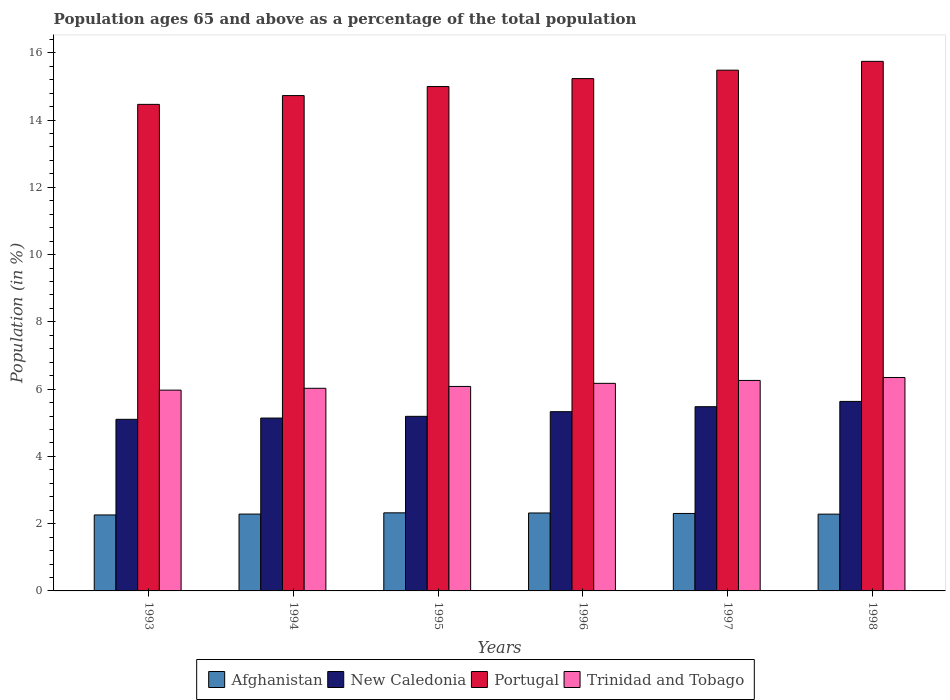Are the number of bars on each tick of the X-axis equal?
Give a very brief answer. Yes. How many bars are there on the 6th tick from the left?
Offer a very short reply. 4. What is the percentage of the population ages 65 and above in Portugal in 1996?
Keep it short and to the point. 15.23. Across all years, what is the maximum percentage of the population ages 65 and above in Trinidad and Tobago?
Make the answer very short. 6.35. Across all years, what is the minimum percentage of the population ages 65 and above in Trinidad and Tobago?
Ensure brevity in your answer.  5.97. In which year was the percentage of the population ages 65 and above in Trinidad and Tobago maximum?
Keep it short and to the point. 1998. What is the total percentage of the population ages 65 and above in Portugal in the graph?
Give a very brief answer. 90.64. What is the difference between the percentage of the population ages 65 and above in Portugal in 1995 and that in 1996?
Your answer should be very brief. -0.24. What is the difference between the percentage of the population ages 65 and above in Afghanistan in 1997 and the percentage of the population ages 65 and above in Portugal in 1995?
Give a very brief answer. -12.69. What is the average percentage of the population ages 65 and above in Trinidad and Tobago per year?
Offer a terse response. 6.14. In the year 1994, what is the difference between the percentage of the population ages 65 and above in New Caledonia and percentage of the population ages 65 and above in Portugal?
Provide a succinct answer. -9.59. What is the ratio of the percentage of the population ages 65 and above in Portugal in 1995 to that in 1996?
Offer a very short reply. 0.98. Is the difference between the percentage of the population ages 65 and above in New Caledonia in 1993 and 1996 greater than the difference between the percentage of the population ages 65 and above in Portugal in 1993 and 1996?
Give a very brief answer. Yes. What is the difference between the highest and the second highest percentage of the population ages 65 and above in Trinidad and Tobago?
Make the answer very short. 0.09. What is the difference between the highest and the lowest percentage of the population ages 65 and above in Portugal?
Your answer should be compact. 1.28. What does the 1st bar from the left in 1996 represents?
Give a very brief answer. Afghanistan. What does the 4th bar from the right in 1995 represents?
Provide a short and direct response. Afghanistan. How many years are there in the graph?
Your answer should be compact. 6. Does the graph contain any zero values?
Ensure brevity in your answer.  No. Does the graph contain grids?
Provide a succinct answer. No. How many legend labels are there?
Provide a succinct answer. 4. What is the title of the graph?
Keep it short and to the point. Population ages 65 and above as a percentage of the total population. What is the label or title of the X-axis?
Ensure brevity in your answer.  Years. What is the label or title of the Y-axis?
Give a very brief answer. Population (in %). What is the Population (in %) of Afghanistan in 1993?
Make the answer very short. 2.26. What is the Population (in %) in New Caledonia in 1993?
Make the answer very short. 5.1. What is the Population (in %) in Portugal in 1993?
Keep it short and to the point. 14.47. What is the Population (in %) of Trinidad and Tobago in 1993?
Provide a succinct answer. 5.97. What is the Population (in %) in Afghanistan in 1994?
Your answer should be compact. 2.28. What is the Population (in %) of New Caledonia in 1994?
Offer a very short reply. 5.14. What is the Population (in %) of Portugal in 1994?
Ensure brevity in your answer.  14.73. What is the Population (in %) in Trinidad and Tobago in 1994?
Your response must be concise. 6.02. What is the Population (in %) in Afghanistan in 1995?
Make the answer very short. 2.32. What is the Population (in %) in New Caledonia in 1995?
Your response must be concise. 5.19. What is the Population (in %) in Portugal in 1995?
Offer a terse response. 15. What is the Population (in %) of Trinidad and Tobago in 1995?
Offer a very short reply. 6.08. What is the Population (in %) of Afghanistan in 1996?
Provide a succinct answer. 2.32. What is the Population (in %) of New Caledonia in 1996?
Offer a terse response. 5.33. What is the Population (in %) of Portugal in 1996?
Provide a short and direct response. 15.23. What is the Population (in %) of Trinidad and Tobago in 1996?
Ensure brevity in your answer.  6.17. What is the Population (in %) in Afghanistan in 1997?
Keep it short and to the point. 2.3. What is the Population (in %) of New Caledonia in 1997?
Provide a succinct answer. 5.48. What is the Population (in %) of Portugal in 1997?
Your answer should be very brief. 15.48. What is the Population (in %) of Trinidad and Tobago in 1997?
Your answer should be very brief. 6.26. What is the Population (in %) in Afghanistan in 1998?
Provide a short and direct response. 2.28. What is the Population (in %) in New Caledonia in 1998?
Provide a short and direct response. 5.63. What is the Population (in %) in Portugal in 1998?
Keep it short and to the point. 15.74. What is the Population (in %) of Trinidad and Tobago in 1998?
Make the answer very short. 6.35. Across all years, what is the maximum Population (in %) in Afghanistan?
Keep it short and to the point. 2.32. Across all years, what is the maximum Population (in %) in New Caledonia?
Give a very brief answer. 5.63. Across all years, what is the maximum Population (in %) in Portugal?
Make the answer very short. 15.74. Across all years, what is the maximum Population (in %) in Trinidad and Tobago?
Offer a terse response. 6.35. Across all years, what is the minimum Population (in %) in Afghanistan?
Provide a succinct answer. 2.26. Across all years, what is the minimum Population (in %) in New Caledonia?
Your answer should be compact. 5.1. Across all years, what is the minimum Population (in %) of Portugal?
Keep it short and to the point. 14.47. Across all years, what is the minimum Population (in %) of Trinidad and Tobago?
Ensure brevity in your answer.  5.97. What is the total Population (in %) in Afghanistan in the graph?
Ensure brevity in your answer.  13.77. What is the total Population (in %) in New Caledonia in the graph?
Your answer should be very brief. 31.87. What is the total Population (in %) of Portugal in the graph?
Your answer should be very brief. 90.64. What is the total Population (in %) in Trinidad and Tobago in the graph?
Your answer should be compact. 36.85. What is the difference between the Population (in %) of Afghanistan in 1993 and that in 1994?
Provide a succinct answer. -0.03. What is the difference between the Population (in %) in New Caledonia in 1993 and that in 1994?
Provide a short and direct response. -0.04. What is the difference between the Population (in %) in Portugal in 1993 and that in 1994?
Your response must be concise. -0.26. What is the difference between the Population (in %) in Trinidad and Tobago in 1993 and that in 1994?
Make the answer very short. -0.05. What is the difference between the Population (in %) of Afghanistan in 1993 and that in 1995?
Make the answer very short. -0.06. What is the difference between the Population (in %) of New Caledonia in 1993 and that in 1995?
Your response must be concise. -0.09. What is the difference between the Population (in %) of Portugal in 1993 and that in 1995?
Make the answer very short. -0.53. What is the difference between the Population (in %) in Trinidad and Tobago in 1993 and that in 1995?
Give a very brief answer. -0.11. What is the difference between the Population (in %) of Afghanistan in 1993 and that in 1996?
Keep it short and to the point. -0.06. What is the difference between the Population (in %) in New Caledonia in 1993 and that in 1996?
Provide a short and direct response. -0.23. What is the difference between the Population (in %) of Portugal in 1993 and that in 1996?
Your answer should be compact. -0.77. What is the difference between the Population (in %) of Trinidad and Tobago in 1993 and that in 1996?
Offer a very short reply. -0.2. What is the difference between the Population (in %) of Afghanistan in 1993 and that in 1997?
Ensure brevity in your answer.  -0.04. What is the difference between the Population (in %) in New Caledonia in 1993 and that in 1997?
Ensure brevity in your answer.  -0.38. What is the difference between the Population (in %) in Portugal in 1993 and that in 1997?
Give a very brief answer. -1.02. What is the difference between the Population (in %) of Trinidad and Tobago in 1993 and that in 1997?
Your answer should be very brief. -0.29. What is the difference between the Population (in %) in Afghanistan in 1993 and that in 1998?
Offer a very short reply. -0.02. What is the difference between the Population (in %) in New Caledonia in 1993 and that in 1998?
Your answer should be compact. -0.53. What is the difference between the Population (in %) of Portugal in 1993 and that in 1998?
Keep it short and to the point. -1.28. What is the difference between the Population (in %) of Trinidad and Tobago in 1993 and that in 1998?
Offer a very short reply. -0.38. What is the difference between the Population (in %) in Afghanistan in 1994 and that in 1995?
Provide a short and direct response. -0.04. What is the difference between the Population (in %) in New Caledonia in 1994 and that in 1995?
Your response must be concise. -0.05. What is the difference between the Population (in %) of Portugal in 1994 and that in 1995?
Your response must be concise. -0.27. What is the difference between the Population (in %) of Trinidad and Tobago in 1994 and that in 1995?
Offer a terse response. -0.05. What is the difference between the Population (in %) of Afghanistan in 1994 and that in 1996?
Offer a very short reply. -0.03. What is the difference between the Population (in %) of New Caledonia in 1994 and that in 1996?
Your response must be concise. -0.19. What is the difference between the Population (in %) of Portugal in 1994 and that in 1996?
Provide a succinct answer. -0.5. What is the difference between the Population (in %) of Trinidad and Tobago in 1994 and that in 1996?
Provide a short and direct response. -0.15. What is the difference between the Population (in %) of Afghanistan in 1994 and that in 1997?
Offer a very short reply. -0.02. What is the difference between the Population (in %) in New Caledonia in 1994 and that in 1997?
Make the answer very short. -0.34. What is the difference between the Population (in %) in Portugal in 1994 and that in 1997?
Your answer should be very brief. -0.76. What is the difference between the Population (in %) in Trinidad and Tobago in 1994 and that in 1997?
Offer a terse response. -0.23. What is the difference between the Population (in %) of Afghanistan in 1994 and that in 1998?
Give a very brief answer. 0. What is the difference between the Population (in %) in New Caledonia in 1994 and that in 1998?
Your response must be concise. -0.49. What is the difference between the Population (in %) of Portugal in 1994 and that in 1998?
Your response must be concise. -1.02. What is the difference between the Population (in %) of Trinidad and Tobago in 1994 and that in 1998?
Ensure brevity in your answer.  -0.32. What is the difference between the Population (in %) of Afghanistan in 1995 and that in 1996?
Provide a short and direct response. 0. What is the difference between the Population (in %) in New Caledonia in 1995 and that in 1996?
Provide a short and direct response. -0.14. What is the difference between the Population (in %) in Portugal in 1995 and that in 1996?
Give a very brief answer. -0.24. What is the difference between the Population (in %) in Trinidad and Tobago in 1995 and that in 1996?
Offer a terse response. -0.09. What is the difference between the Population (in %) in Afghanistan in 1995 and that in 1997?
Make the answer very short. 0.02. What is the difference between the Population (in %) in New Caledonia in 1995 and that in 1997?
Your answer should be very brief. -0.29. What is the difference between the Population (in %) in Portugal in 1995 and that in 1997?
Your answer should be compact. -0.49. What is the difference between the Population (in %) in Trinidad and Tobago in 1995 and that in 1997?
Offer a very short reply. -0.18. What is the difference between the Population (in %) of Afghanistan in 1995 and that in 1998?
Provide a short and direct response. 0.04. What is the difference between the Population (in %) of New Caledonia in 1995 and that in 1998?
Offer a terse response. -0.44. What is the difference between the Population (in %) in Portugal in 1995 and that in 1998?
Make the answer very short. -0.75. What is the difference between the Population (in %) in Trinidad and Tobago in 1995 and that in 1998?
Your answer should be very brief. -0.27. What is the difference between the Population (in %) of Afghanistan in 1996 and that in 1997?
Provide a succinct answer. 0.01. What is the difference between the Population (in %) of New Caledonia in 1996 and that in 1997?
Provide a succinct answer. -0.15. What is the difference between the Population (in %) of Portugal in 1996 and that in 1997?
Your answer should be compact. -0.25. What is the difference between the Population (in %) of Trinidad and Tobago in 1996 and that in 1997?
Your answer should be compact. -0.09. What is the difference between the Population (in %) of Afghanistan in 1996 and that in 1998?
Provide a short and direct response. 0.03. What is the difference between the Population (in %) in New Caledonia in 1996 and that in 1998?
Offer a very short reply. -0.3. What is the difference between the Population (in %) in Portugal in 1996 and that in 1998?
Give a very brief answer. -0.51. What is the difference between the Population (in %) in Trinidad and Tobago in 1996 and that in 1998?
Provide a succinct answer. -0.17. What is the difference between the Population (in %) of Afghanistan in 1997 and that in 1998?
Ensure brevity in your answer.  0.02. What is the difference between the Population (in %) of New Caledonia in 1997 and that in 1998?
Offer a very short reply. -0.16. What is the difference between the Population (in %) of Portugal in 1997 and that in 1998?
Offer a terse response. -0.26. What is the difference between the Population (in %) of Trinidad and Tobago in 1997 and that in 1998?
Offer a very short reply. -0.09. What is the difference between the Population (in %) of Afghanistan in 1993 and the Population (in %) of New Caledonia in 1994?
Offer a very short reply. -2.88. What is the difference between the Population (in %) of Afghanistan in 1993 and the Population (in %) of Portugal in 1994?
Make the answer very short. -12.47. What is the difference between the Population (in %) of Afghanistan in 1993 and the Population (in %) of Trinidad and Tobago in 1994?
Your response must be concise. -3.77. What is the difference between the Population (in %) of New Caledonia in 1993 and the Population (in %) of Portugal in 1994?
Ensure brevity in your answer.  -9.63. What is the difference between the Population (in %) in New Caledonia in 1993 and the Population (in %) in Trinidad and Tobago in 1994?
Make the answer very short. -0.92. What is the difference between the Population (in %) in Portugal in 1993 and the Population (in %) in Trinidad and Tobago in 1994?
Make the answer very short. 8.44. What is the difference between the Population (in %) in Afghanistan in 1993 and the Population (in %) in New Caledonia in 1995?
Provide a short and direct response. -2.93. What is the difference between the Population (in %) of Afghanistan in 1993 and the Population (in %) of Portugal in 1995?
Keep it short and to the point. -12.74. What is the difference between the Population (in %) in Afghanistan in 1993 and the Population (in %) in Trinidad and Tobago in 1995?
Give a very brief answer. -3.82. What is the difference between the Population (in %) of New Caledonia in 1993 and the Population (in %) of Portugal in 1995?
Make the answer very short. -9.89. What is the difference between the Population (in %) of New Caledonia in 1993 and the Population (in %) of Trinidad and Tobago in 1995?
Give a very brief answer. -0.98. What is the difference between the Population (in %) in Portugal in 1993 and the Population (in %) in Trinidad and Tobago in 1995?
Keep it short and to the point. 8.39. What is the difference between the Population (in %) in Afghanistan in 1993 and the Population (in %) in New Caledonia in 1996?
Your answer should be very brief. -3.07. What is the difference between the Population (in %) in Afghanistan in 1993 and the Population (in %) in Portugal in 1996?
Offer a terse response. -12.97. What is the difference between the Population (in %) in Afghanistan in 1993 and the Population (in %) in Trinidad and Tobago in 1996?
Make the answer very short. -3.91. What is the difference between the Population (in %) of New Caledonia in 1993 and the Population (in %) of Portugal in 1996?
Ensure brevity in your answer.  -10.13. What is the difference between the Population (in %) in New Caledonia in 1993 and the Population (in %) in Trinidad and Tobago in 1996?
Offer a very short reply. -1.07. What is the difference between the Population (in %) in Portugal in 1993 and the Population (in %) in Trinidad and Tobago in 1996?
Give a very brief answer. 8.29. What is the difference between the Population (in %) in Afghanistan in 1993 and the Population (in %) in New Caledonia in 1997?
Offer a terse response. -3.22. What is the difference between the Population (in %) of Afghanistan in 1993 and the Population (in %) of Portugal in 1997?
Give a very brief answer. -13.22. What is the difference between the Population (in %) in Afghanistan in 1993 and the Population (in %) in Trinidad and Tobago in 1997?
Your answer should be compact. -4. What is the difference between the Population (in %) in New Caledonia in 1993 and the Population (in %) in Portugal in 1997?
Provide a short and direct response. -10.38. What is the difference between the Population (in %) of New Caledonia in 1993 and the Population (in %) of Trinidad and Tobago in 1997?
Your answer should be compact. -1.16. What is the difference between the Population (in %) in Portugal in 1993 and the Population (in %) in Trinidad and Tobago in 1997?
Keep it short and to the point. 8.21. What is the difference between the Population (in %) of Afghanistan in 1993 and the Population (in %) of New Caledonia in 1998?
Make the answer very short. -3.38. What is the difference between the Population (in %) of Afghanistan in 1993 and the Population (in %) of Portugal in 1998?
Provide a succinct answer. -13.49. What is the difference between the Population (in %) of Afghanistan in 1993 and the Population (in %) of Trinidad and Tobago in 1998?
Provide a short and direct response. -4.09. What is the difference between the Population (in %) in New Caledonia in 1993 and the Population (in %) in Portugal in 1998?
Your answer should be very brief. -10.64. What is the difference between the Population (in %) of New Caledonia in 1993 and the Population (in %) of Trinidad and Tobago in 1998?
Give a very brief answer. -1.24. What is the difference between the Population (in %) in Portugal in 1993 and the Population (in %) in Trinidad and Tobago in 1998?
Give a very brief answer. 8.12. What is the difference between the Population (in %) of Afghanistan in 1994 and the Population (in %) of New Caledonia in 1995?
Your response must be concise. -2.91. What is the difference between the Population (in %) in Afghanistan in 1994 and the Population (in %) in Portugal in 1995?
Provide a short and direct response. -12.71. What is the difference between the Population (in %) of Afghanistan in 1994 and the Population (in %) of Trinidad and Tobago in 1995?
Make the answer very short. -3.79. What is the difference between the Population (in %) of New Caledonia in 1994 and the Population (in %) of Portugal in 1995?
Ensure brevity in your answer.  -9.86. What is the difference between the Population (in %) of New Caledonia in 1994 and the Population (in %) of Trinidad and Tobago in 1995?
Provide a short and direct response. -0.94. What is the difference between the Population (in %) of Portugal in 1994 and the Population (in %) of Trinidad and Tobago in 1995?
Provide a short and direct response. 8.65. What is the difference between the Population (in %) of Afghanistan in 1994 and the Population (in %) of New Caledonia in 1996?
Make the answer very short. -3.04. What is the difference between the Population (in %) of Afghanistan in 1994 and the Population (in %) of Portugal in 1996?
Keep it short and to the point. -12.95. What is the difference between the Population (in %) in Afghanistan in 1994 and the Population (in %) in Trinidad and Tobago in 1996?
Make the answer very short. -3.89. What is the difference between the Population (in %) in New Caledonia in 1994 and the Population (in %) in Portugal in 1996?
Make the answer very short. -10.09. What is the difference between the Population (in %) in New Caledonia in 1994 and the Population (in %) in Trinidad and Tobago in 1996?
Offer a terse response. -1.03. What is the difference between the Population (in %) in Portugal in 1994 and the Population (in %) in Trinidad and Tobago in 1996?
Ensure brevity in your answer.  8.56. What is the difference between the Population (in %) of Afghanistan in 1994 and the Population (in %) of New Caledonia in 1997?
Make the answer very short. -3.19. What is the difference between the Population (in %) in Afghanistan in 1994 and the Population (in %) in Portugal in 1997?
Your answer should be very brief. -13.2. What is the difference between the Population (in %) of Afghanistan in 1994 and the Population (in %) of Trinidad and Tobago in 1997?
Your answer should be compact. -3.97. What is the difference between the Population (in %) of New Caledonia in 1994 and the Population (in %) of Portugal in 1997?
Make the answer very short. -10.34. What is the difference between the Population (in %) in New Caledonia in 1994 and the Population (in %) in Trinidad and Tobago in 1997?
Ensure brevity in your answer.  -1.12. What is the difference between the Population (in %) of Portugal in 1994 and the Population (in %) of Trinidad and Tobago in 1997?
Offer a very short reply. 8.47. What is the difference between the Population (in %) of Afghanistan in 1994 and the Population (in %) of New Caledonia in 1998?
Give a very brief answer. -3.35. What is the difference between the Population (in %) of Afghanistan in 1994 and the Population (in %) of Portugal in 1998?
Your response must be concise. -13.46. What is the difference between the Population (in %) of Afghanistan in 1994 and the Population (in %) of Trinidad and Tobago in 1998?
Offer a very short reply. -4.06. What is the difference between the Population (in %) in New Caledonia in 1994 and the Population (in %) in Portugal in 1998?
Your response must be concise. -10.6. What is the difference between the Population (in %) of New Caledonia in 1994 and the Population (in %) of Trinidad and Tobago in 1998?
Give a very brief answer. -1.21. What is the difference between the Population (in %) of Portugal in 1994 and the Population (in %) of Trinidad and Tobago in 1998?
Ensure brevity in your answer.  8.38. What is the difference between the Population (in %) of Afghanistan in 1995 and the Population (in %) of New Caledonia in 1996?
Keep it short and to the point. -3.01. What is the difference between the Population (in %) in Afghanistan in 1995 and the Population (in %) in Portugal in 1996?
Ensure brevity in your answer.  -12.91. What is the difference between the Population (in %) of Afghanistan in 1995 and the Population (in %) of Trinidad and Tobago in 1996?
Give a very brief answer. -3.85. What is the difference between the Population (in %) of New Caledonia in 1995 and the Population (in %) of Portugal in 1996?
Offer a very short reply. -10.04. What is the difference between the Population (in %) of New Caledonia in 1995 and the Population (in %) of Trinidad and Tobago in 1996?
Give a very brief answer. -0.98. What is the difference between the Population (in %) in Portugal in 1995 and the Population (in %) in Trinidad and Tobago in 1996?
Ensure brevity in your answer.  8.82. What is the difference between the Population (in %) in Afghanistan in 1995 and the Population (in %) in New Caledonia in 1997?
Make the answer very short. -3.16. What is the difference between the Population (in %) in Afghanistan in 1995 and the Population (in %) in Portugal in 1997?
Keep it short and to the point. -13.16. What is the difference between the Population (in %) of Afghanistan in 1995 and the Population (in %) of Trinidad and Tobago in 1997?
Your answer should be compact. -3.94. What is the difference between the Population (in %) of New Caledonia in 1995 and the Population (in %) of Portugal in 1997?
Offer a very short reply. -10.29. What is the difference between the Population (in %) of New Caledonia in 1995 and the Population (in %) of Trinidad and Tobago in 1997?
Your answer should be compact. -1.07. What is the difference between the Population (in %) in Portugal in 1995 and the Population (in %) in Trinidad and Tobago in 1997?
Your response must be concise. 8.74. What is the difference between the Population (in %) of Afghanistan in 1995 and the Population (in %) of New Caledonia in 1998?
Your response must be concise. -3.31. What is the difference between the Population (in %) of Afghanistan in 1995 and the Population (in %) of Portugal in 1998?
Provide a short and direct response. -13.42. What is the difference between the Population (in %) of Afghanistan in 1995 and the Population (in %) of Trinidad and Tobago in 1998?
Your response must be concise. -4.02. What is the difference between the Population (in %) of New Caledonia in 1995 and the Population (in %) of Portugal in 1998?
Keep it short and to the point. -10.55. What is the difference between the Population (in %) of New Caledonia in 1995 and the Population (in %) of Trinidad and Tobago in 1998?
Ensure brevity in your answer.  -1.16. What is the difference between the Population (in %) in Portugal in 1995 and the Population (in %) in Trinidad and Tobago in 1998?
Your response must be concise. 8.65. What is the difference between the Population (in %) in Afghanistan in 1996 and the Population (in %) in New Caledonia in 1997?
Give a very brief answer. -3.16. What is the difference between the Population (in %) of Afghanistan in 1996 and the Population (in %) of Portugal in 1997?
Offer a very short reply. -13.16. What is the difference between the Population (in %) in Afghanistan in 1996 and the Population (in %) in Trinidad and Tobago in 1997?
Your answer should be compact. -3.94. What is the difference between the Population (in %) of New Caledonia in 1996 and the Population (in %) of Portugal in 1997?
Offer a very short reply. -10.15. What is the difference between the Population (in %) of New Caledonia in 1996 and the Population (in %) of Trinidad and Tobago in 1997?
Your answer should be very brief. -0.93. What is the difference between the Population (in %) in Portugal in 1996 and the Population (in %) in Trinidad and Tobago in 1997?
Offer a very short reply. 8.97. What is the difference between the Population (in %) of Afghanistan in 1996 and the Population (in %) of New Caledonia in 1998?
Keep it short and to the point. -3.32. What is the difference between the Population (in %) of Afghanistan in 1996 and the Population (in %) of Portugal in 1998?
Make the answer very short. -13.43. What is the difference between the Population (in %) in Afghanistan in 1996 and the Population (in %) in Trinidad and Tobago in 1998?
Ensure brevity in your answer.  -4.03. What is the difference between the Population (in %) in New Caledonia in 1996 and the Population (in %) in Portugal in 1998?
Give a very brief answer. -10.41. What is the difference between the Population (in %) in New Caledonia in 1996 and the Population (in %) in Trinidad and Tobago in 1998?
Keep it short and to the point. -1.02. What is the difference between the Population (in %) in Portugal in 1996 and the Population (in %) in Trinidad and Tobago in 1998?
Provide a succinct answer. 8.89. What is the difference between the Population (in %) in Afghanistan in 1997 and the Population (in %) in New Caledonia in 1998?
Provide a succinct answer. -3.33. What is the difference between the Population (in %) in Afghanistan in 1997 and the Population (in %) in Portugal in 1998?
Your answer should be compact. -13.44. What is the difference between the Population (in %) in Afghanistan in 1997 and the Population (in %) in Trinidad and Tobago in 1998?
Provide a succinct answer. -4.04. What is the difference between the Population (in %) in New Caledonia in 1997 and the Population (in %) in Portugal in 1998?
Provide a short and direct response. -10.27. What is the difference between the Population (in %) in New Caledonia in 1997 and the Population (in %) in Trinidad and Tobago in 1998?
Offer a very short reply. -0.87. What is the difference between the Population (in %) in Portugal in 1997 and the Population (in %) in Trinidad and Tobago in 1998?
Make the answer very short. 9.14. What is the average Population (in %) in Afghanistan per year?
Ensure brevity in your answer.  2.29. What is the average Population (in %) in New Caledonia per year?
Your answer should be very brief. 5.31. What is the average Population (in %) of Portugal per year?
Ensure brevity in your answer.  15.11. What is the average Population (in %) of Trinidad and Tobago per year?
Your answer should be very brief. 6.14. In the year 1993, what is the difference between the Population (in %) in Afghanistan and Population (in %) in New Caledonia?
Offer a very short reply. -2.84. In the year 1993, what is the difference between the Population (in %) of Afghanistan and Population (in %) of Portugal?
Ensure brevity in your answer.  -12.21. In the year 1993, what is the difference between the Population (in %) in Afghanistan and Population (in %) in Trinidad and Tobago?
Keep it short and to the point. -3.71. In the year 1993, what is the difference between the Population (in %) of New Caledonia and Population (in %) of Portugal?
Your answer should be compact. -9.36. In the year 1993, what is the difference between the Population (in %) in New Caledonia and Population (in %) in Trinidad and Tobago?
Make the answer very short. -0.87. In the year 1993, what is the difference between the Population (in %) of Portugal and Population (in %) of Trinidad and Tobago?
Make the answer very short. 8.5. In the year 1994, what is the difference between the Population (in %) in Afghanistan and Population (in %) in New Caledonia?
Your answer should be very brief. -2.85. In the year 1994, what is the difference between the Population (in %) in Afghanistan and Population (in %) in Portugal?
Ensure brevity in your answer.  -12.44. In the year 1994, what is the difference between the Population (in %) in Afghanistan and Population (in %) in Trinidad and Tobago?
Give a very brief answer. -3.74. In the year 1994, what is the difference between the Population (in %) in New Caledonia and Population (in %) in Portugal?
Make the answer very short. -9.59. In the year 1994, what is the difference between the Population (in %) of New Caledonia and Population (in %) of Trinidad and Tobago?
Your answer should be very brief. -0.88. In the year 1994, what is the difference between the Population (in %) in Portugal and Population (in %) in Trinidad and Tobago?
Provide a short and direct response. 8.7. In the year 1995, what is the difference between the Population (in %) in Afghanistan and Population (in %) in New Caledonia?
Your answer should be very brief. -2.87. In the year 1995, what is the difference between the Population (in %) in Afghanistan and Population (in %) in Portugal?
Keep it short and to the point. -12.67. In the year 1995, what is the difference between the Population (in %) of Afghanistan and Population (in %) of Trinidad and Tobago?
Your answer should be very brief. -3.76. In the year 1995, what is the difference between the Population (in %) in New Caledonia and Population (in %) in Portugal?
Your answer should be very brief. -9.8. In the year 1995, what is the difference between the Population (in %) of New Caledonia and Population (in %) of Trinidad and Tobago?
Offer a terse response. -0.89. In the year 1995, what is the difference between the Population (in %) of Portugal and Population (in %) of Trinidad and Tobago?
Your answer should be very brief. 8.92. In the year 1996, what is the difference between the Population (in %) in Afghanistan and Population (in %) in New Caledonia?
Keep it short and to the point. -3.01. In the year 1996, what is the difference between the Population (in %) of Afghanistan and Population (in %) of Portugal?
Your response must be concise. -12.91. In the year 1996, what is the difference between the Population (in %) in Afghanistan and Population (in %) in Trinidad and Tobago?
Provide a succinct answer. -3.85. In the year 1996, what is the difference between the Population (in %) in New Caledonia and Population (in %) in Portugal?
Provide a succinct answer. -9.9. In the year 1996, what is the difference between the Population (in %) in New Caledonia and Population (in %) in Trinidad and Tobago?
Make the answer very short. -0.84. In the year 1996, what is the difference between the Population (in %) of Portugal and Population (in %) of Trinidad and Tobago?
Offer a very short reply. 9.06. In the year 1997, what is the difference between the Population (in %) in Afghanistan and Population (in %) in New Caledonia?
Provide a short and direct response. -3.17. In the year 1997, what is the difference between the Population (in %) of Afghanistan and Population (in %) of Portugal?
Your answer should be compact. -13.18. In the year 1997, what is the difference between the Population (in %) of Afghanistan and Population (in %) of Trinidad and Tobago?
Make the answer very short. -3.96. In the year 1997, what is the difference between the Population (in %) of New Caledonia and Population (in %) of Portugal?
Keep it short and to the point. -10. In the year 1997, what is the difference between the Population (in %) of New Caledonia and Population (in %) of Trinidad and Tobago?
Your answer should be compact. -0.78. In the year 1997, what is the difference between the Population (in %) of Portugal and Population (in %) of Trinidad and Tobago?
Offer a terse response. 9.22. In the year 1998, what is the difference between the Population (in %) of Afghanistan and Population (in %) of New Caledonia?
Provide a short and direct response. -3.35. In the year 1998, what is the difference between the Population (in %) in Afghanistan and Population (in %) in Portugal?
Your response must be concise. -13.46. In the year 1998, what is the difference between the Population (in %) of Afghanistan and Population (in %) of Trinidad and Tobago?
Provide a succinct answer. -4.06. In the year 1998, what is the difference between the Population (in %) of New Caledonia and Population (in %) of Portugal?
Offer a very short reply. -10.11. In the year 1998, what is the difference between the Population (in %) of New Caledonia and Population (in %) of Trinidad and Tobago?
Provide a short and direct response. -0.71. In the year 1998, what is the difference between the Population (in %) of Portugal and Population (in %) of Trinidad and Tobago?
Offer a very short reply. 9.4. What is the ratio of the Population (in %) in Afghanistan in 1993 to that in 1994?
Provide a succinct answer. 0.99. What is the ratio of the Population (in %) of Portugal in 1993 to that in 1994?
Keep it short and to the point. 0.98. What is the ratio of the Population (in %) of Trinidad and Tobago in 1993 to that in 1994?
Offer a terse response. 0.99. What is the ratio of the Population (in %) of Afghanistan in 1993 to that in 1995?
Make the answer very short. 0.97. What is the ratio of the Population (in %) of New Caledonia in 1993 to that in 1995?
Offer a terse response. 0.98. What is the ratio of the Population (in %) of Portugal in 1993 to that in 1995?
Give a very brief answer. 0.96. What is the ratio of the Population (in %) in Afghanistan in 1993 to that in 1996?
Ensure brevity in your answer.  0.97. What is the ratio of the Population (in %) of New Caledonia in 1993 to that in 1996?
Ensure brevity in your answer.  0.96. What is the ratio of the Population (in %) of Portugal in 1993 to that in 1996?
Your answer should be compact. 0.95. What is the ratio of the Population (in %) in Trinidad and Tobago in 1993 to that in 1996?
Make the answer very short. 0.97. What is the ratio of the Population (in %) of Afghanistan in 1993 to that in 1997?
Offer a terse response. 0.98. What is the ratio of the Population (in %) of New Caledonia in 1993 to that in 1997?
Your response must be concise. 0.93. What is the ratio of the Population (in %) in Portugal in 1993 to that in 1997?
Keep it short and to the point. 0.93. What is the ratio of the Population (in %) of Trinidad and Tobago in 1993 to that in 1997?
Give a very brief answer. 0.95. What is the ratio of the Population (in %) of New Caledonia in 1993 to that in 1998?
Your answer should be compact. 0.91. What is the ratio of the Population (in %) of Portugal in 1993 to that in 1998?
Make the answer very short. 0.92. What is the ratio of the Population (in %) of Trinidad and Tobago in 1993 to that in 1998?
Your answer should be compact. 0.94. What is the ratio of the Population (in %) in Afghanistan in 1994 to that in 1995?
Provide a short and direct response. 0.98. What is the ratio of the Population (in %) of New Caledonia in 1994 to that in 1995?
Your answer should be very brief. 0.99. What is the ratio of the Population (in %) of Portugal in 1994 to that in 1995?
Give a very brief answer. 0.98. What is the ratio of the Population (in %) of Afghanistan in 1994 to that in 1996?
Offer a terse response. 0.99. What is the ratio of the Population (in %) in New Caledonia in 1994 to that in 1996?
Offer a very short reply. 0.96. What is the ratio of the Population (in %) of Portugal in 1994 to that in 1996?
Provide a short and direct response. 0.97. What is the ratio of the Population (in %) in Trinidad and Tobago in 1994 to that in 1996?
Ensure brevity in your answer.  0.98. What is the ratio of the Population (in %) in New Caledonia in 1994 to that in 1997?
Keep it short and to the point. 0.94. What is the ratio of the Population (in %) of Portugal in 1994 to that in 1997?
Your answer should be compact. 0.95. What is the ratio of the Population (in %) in Trinidad and Tobago in 1994 to that in 1997?
Provide a short and direct response. 0.96. What is the ratio of the Population (in %) in Afghanistan in 1994 to that in 1998?
Keep it short and to the point. 1. What is the ratio of the Population (in %) in New Caledonia in 1994 to that in 1998?
Offer a very short reply. 0.91. What is the ratio of the Population (in %) in Portugal in 1994 to that in 1998?
Offer a terse response. 0.94. What is the ratio of the Population (in %) of Trinidad and Tobago in 1994 to that in 1998?
Your answer should be very brief. 0.95. What is the ratio of the Population (in %) of Afghanistan in 1995 to that in 1996?
Keep it short and to the point. 1. What is the ratio of the Population (in %) in New Caledonia in 1995 to that in 1996?
Your answer should be very brief. 0.97. What is the ratio of the Population (in %) of Portugal in 1995 to that in 1996?
Your answer should be very brief. 0.98. What is the ratio of the Population (in %) of Trinidad and Tobago in 1995 to that in 1996?
Offer a terse response. 0.99. What is the ratio of the Population (in %) in New Caledonia in 1995 to that in 1997?
Keep it short and to the point. 0.95. What is the ratio of the Population (in %) in Portugal in 1995 to that in 1997?
Keep it short and to the point. 0.97. What is the ratio of the Population (in %) in Trinidad and Tobago in 1995 to that in 1997?
Your answer should be very brief. 0.97. What is the ratio of the Population (in %) in Afghanistan in 1995 to that in 1998?
Your answer should be very brief. 1.02. What is the ratio of the Population (in %) of New Caledonia in 1995 to that in 1998?
Offer a terse response. 0.92. What is the ratio of the Population (in %) of Trinidad and Tobago in 1995 to that in 1998?
Make the answer very short. 0.96. What is the ratio of the Population (in %) in Afghanistan in 1996 to that in 1997?
Keep it short and to the point. 1.01. What is the ratio of the Population (in %) in Portugal in 1996 to that in 1997?
Keep it short and to the point. 0.98. What is the ratio of the Population (in %) in Trinidad and Tobago in 1996 to that in 1997?
Keep it short and to the point. 0.99. What is the ratio of the Population (in %) in Afghanistan in 1996 to that in 1998?
Provide a succinct answer. 1.01. What is the ratio of the Population (in %) in New Caledonia in 1996 to that in 1998?
Provide a short and direct response. 0.95. What is the ratio of the Population (in %) in Portugal in 1996 to that in 1998?
Ensure brevity in your answer.  0.97. What is the ratio of the Population (in %) of Trinidad and Tobago in 1996 to that in 1998?
Provide a short and direct response. 0.97. What is the ratio of the Population (in %) of Afghanistan in 1997 to that in 1998?
Your answer should be very brief. 1.01. What is the ratio of the Population (in %) in New Caledonia in 1997 to that in 1998?
Offer a terse response. 0.97. What is the ratio of the Population (in %) in Portugal in 1997 to that in 1998?
Your response must be concise. 0.98. What is the ratio of the Population (in %) in Trinidad and Tobago in 1997 to that in 1998?
Provide a short and direct response. 0.99. What is the difference between the highest and the second highest Population (in %) of Afghanistan?
Offer a terse response. 0. What is the difference between the highest and the second highest Population (in %) of New Caledonia?
Provide a succinct answer. 0.16. What is the difference between the highest and the second highest Population (in %) in Portugal?
Your answer should be compact. 0.26. What is the difference between the highest and the second highest Population (in %) of Trinidad and Tobago?
Give a very brief answer. 0.09. What is the difference between the highest and the lowest Population (in %) of Afghanistan?
Keep it short and to the point. 0.06. What is the difference between the highest and the lowest Population (in %) in New Caledonia?
Give a very brief answer. 0.53. What is the difference between the highest and the lowest Population (in %) of Portugal?
Offer a terse response. 1.28. What is the difference between the highest and the lowest Population (in %) in Trinidad and Tobago?
Your answer should be compact. 0.38. 